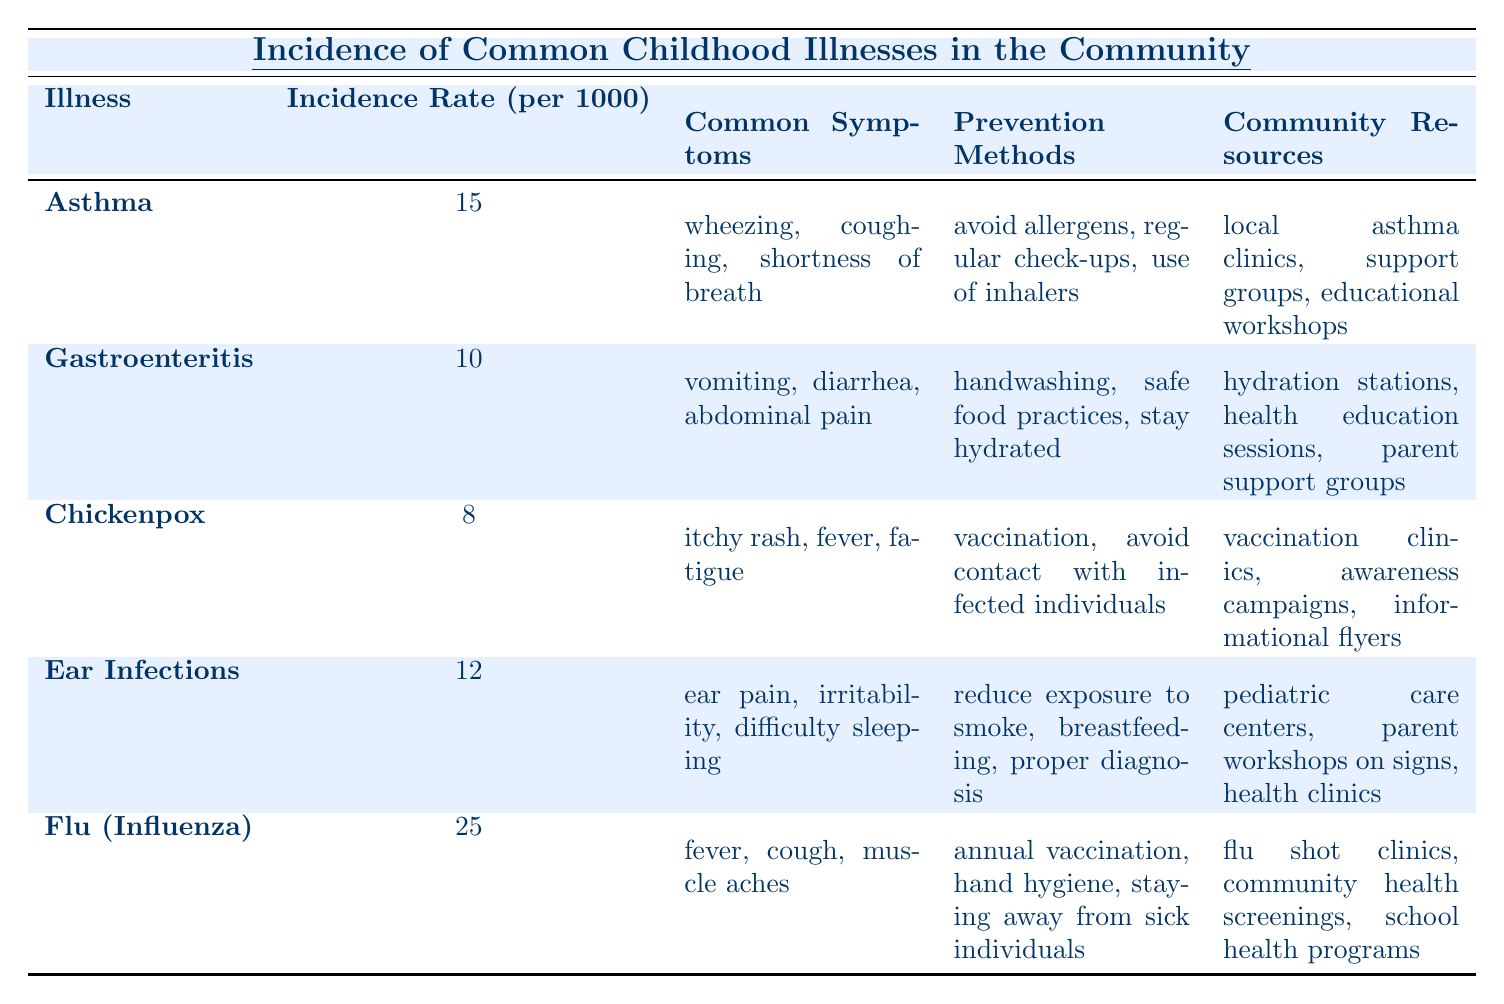What is the incidence rate of Flu (Influenza)? The table states that the incidence rate of Flu (Influenza) is listed under the corresponding column. Referring to that entry, it is 25 per 1000.
Answer: 25 Which illness has the highest incidence rate? By comparing the incidence rates for each illness listed in the table, Flu (Influenza) has the highest rate at 25 per 1000.
Answer: Flu (Influenza) How many common symptoms does Asthma have? The table lists three common symptoms for Asthma: wheezing, coughing, and shortness of breath. This is a direct count of listed symptoms.
Answer: 3 What prevention methods are advised for Gastroenteritis? The prevention methods for Gastroenteritis can be found directly under its heading in the table, which are handwashing, safe food practices, and staying hydrated.
Answer: Handwashing, safe food practices, stay hydrated Is the incidence rate of Chickenpox higher than that of Gastroenteritis? The incidence rate of Chickenpox is 8 per 1000, and for Gastroenteritis, it is 10 per 1000. Since 8 is not greater than 10, the statement is false.
Answer: No What is the average incidence rate of the five illnesses listed? First, add up all incidence rates: 15 (Asthma) + 10 (Gastroenteritis) + 8 (Chickenpox) + 12 (Ear Infections) + 25 (Flu) = 70. There are 5 illnesses, so divide 70 by 5, which equals 14.
Answer: 14 Are the common symptoms for Ear Infections the same as those for Chickenpox? The common symptoms for Ear Infections are ear pain, irritability, and difficulty sleeping, while for Chickenpox, they are itchy rash, fever, and fatigue. Since these lists are different, the answer is no.
Answer: No How many community resources are related to Asthma? The table lists three community resources related to Asthma: local asthma clinics, support groups, and educational workshops. This gives us a clear count directly from the table.
Answer: 3 Which illness has the least number of common symptoms? Chickenpox has three common symptoms, while the others have more. Flu and Ear Infections both have distinct symptoms that exceed that count. Therefore, Chickenpox has the least number of common symptoms.
Answer: Chickenpox What is the difference in incidence rates between Ear Infections and Chickenpox? Ear Infections have an incidence rate of 12 per 1000, and Chickenpox has 8 per 1000. The difference is calculated by subtracting 8 from 12, resulting in 4.
Answer: 4 List one community resource for each illness. From the table, one resource can be extracted for each illness: Local asthma clinics for Asthma, hydration stations for Gastroenteritis, vaccination clinics for Chickenpox, pediatric care centers for Ear Infections, and flu shot clinics for Flu.
Answer: Local asthma clinics, hydration stations, vaccination clinics, pediatric care centers, flu shot clinics 